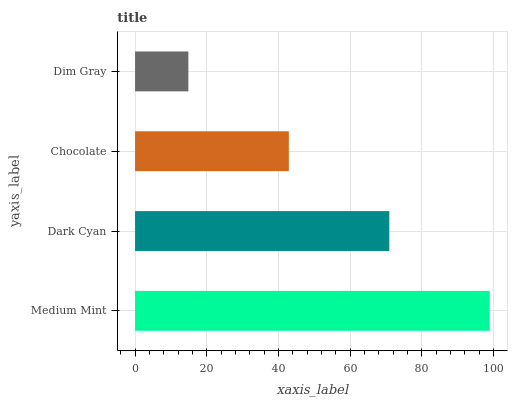Is Dim Gray the minimum?
Answer yes or no. Yes. Is Medium Mint the maximum?
Answer yes or no. Yes. Is Dark Cyan the minimum?
Answer yes or no. No. Is Dark Cyan the maximum?
Answer yes or no. No. Is Medium Mint greater than Dark Cyan?
Answer yes or no. Yes. Is Dark Cyan less than Medium Mint?
Answer yes or no. Yes. Is Dark Cyan greater than Medium Mint?
Answer yes or no. No. Is Medium Mint less than Dark Cyan?
Answer yes or no. No. Is Dark Cyan the high median?
Answer yes or no. Yes. Is Chocolate the low median?
Answer yes or no. Yes. Is Chocolate the high median?
Answer yes or no. No. Is Dim Gray the low median?
Answer yes or no. No. 